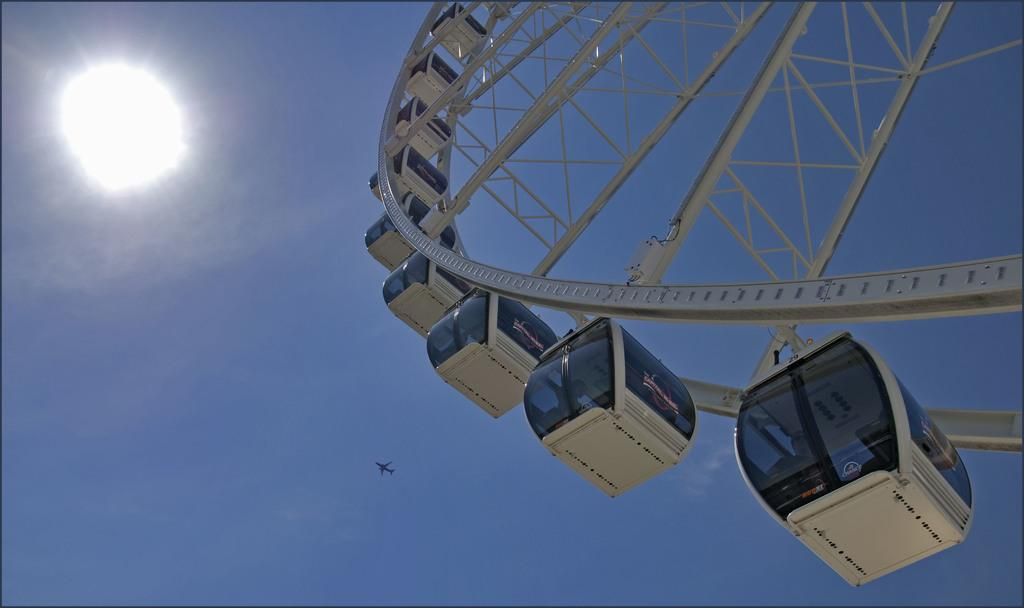What type of attraction is featured in the image? There is an amusement ride in the image. What else can be seen in the image besides the amusement ride? There is an aeroplane in the image. What is the color of the sky in the image? The sky is blue in color. Can you describe the sun's appearance in the image? The sun is visible in the image and appears to be shiny. Where is the writer sitting while observing the amusement ride in the image? There is no writer present in the image, so it is not possible to determine where they might be sitting. 